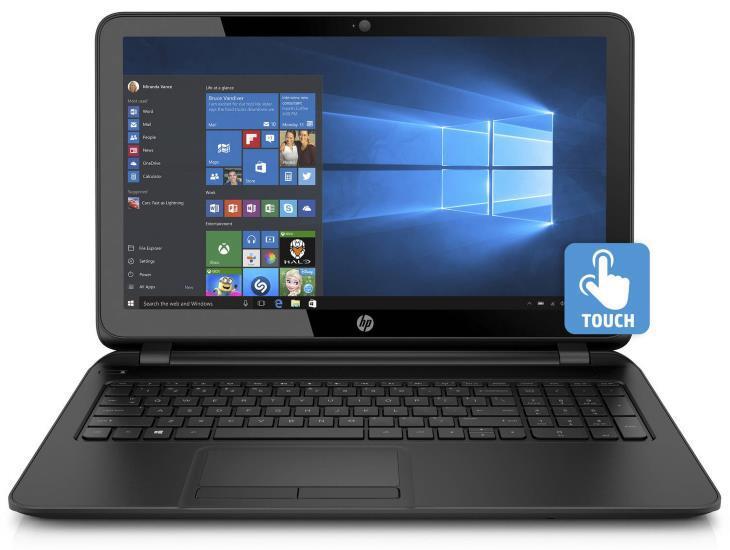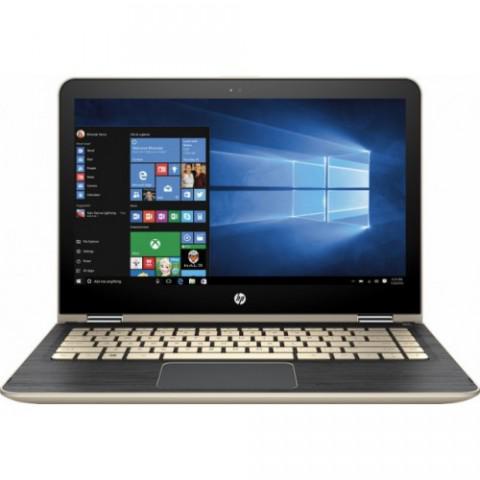The first image is the image on the left, the second image is the image on the right. Examine the images to the left and right. Is the description "Each open laptop is displayed head-on, and each screen contains a square with a black background on the left and glowing blue light that radiates leftward." accurate? Answer yes or no. Yes. The first image is the image on the left, the second image is the image on the right. For the images displayed, is the sentence "Two laptop computers facing front are open with start screens showing, but with different colored keyboards." factually correct? Answer yes or no. Yes. 